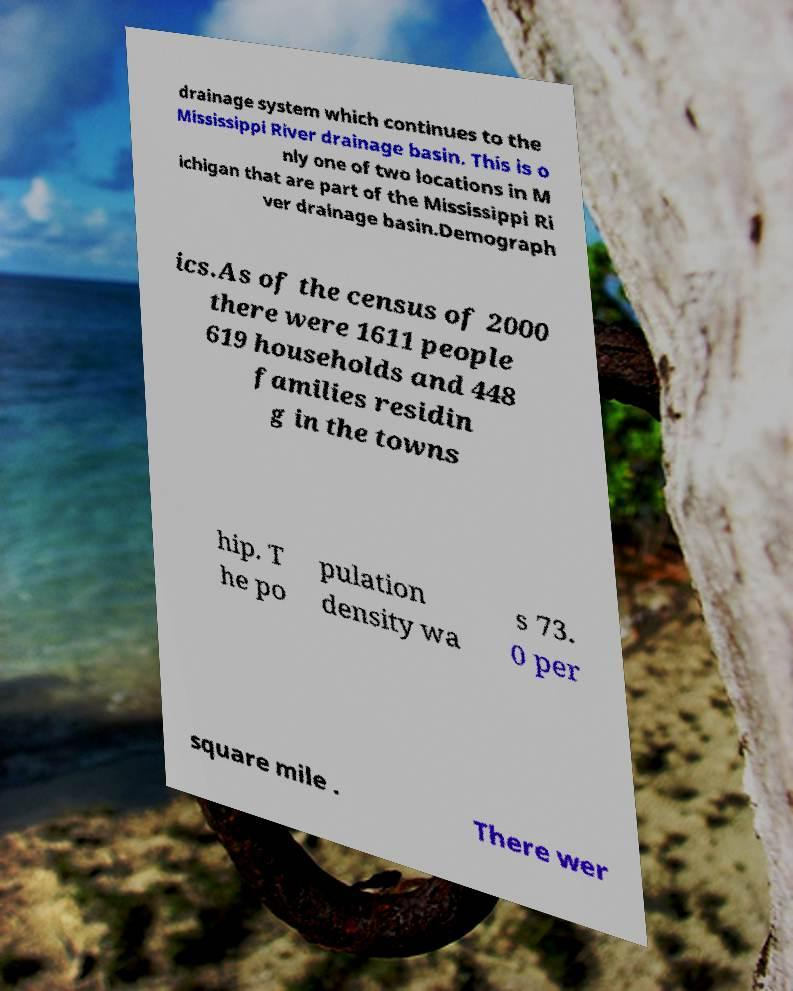Could you assist in decoding the text presented in this image and type it out clearly? drainage system which continues to the Mississippi River drainage basin. This is o nly one of two locations in M ichigan that are part of the Mississippi Ri ver drainage basin.Demograph ics.As of the census of 2000 there were 1611 people 619 households and 448 families residin g in the towns hip. T he po pulation density wa s 73. 0 per square mile . There wer 